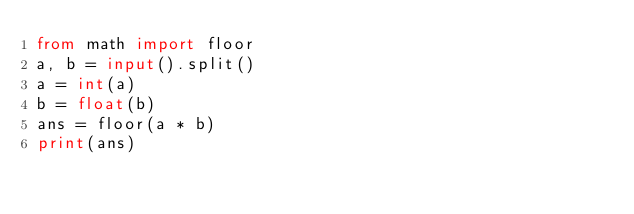<code> <loc_0><loc_0><loc_500><loc_500><_Python_>from math import floor
a, b = input().split()
a = int(a)
b = float(b)
ans = floor(a * b)
print(ans)
</code> 